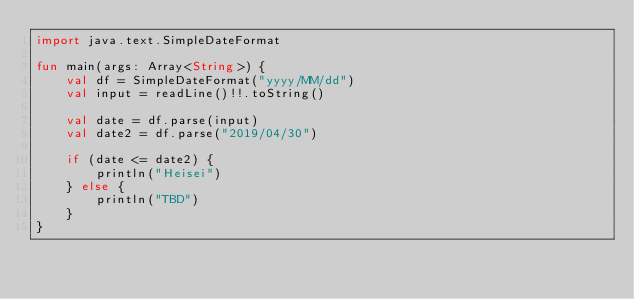<code> <loc_0><loc_0><loc_500><loc_500><_Kotlin_>import java.text.SimpleDateFormat

fun main(args: Array<String>) {
    val df = SimpleDateFormat("yyyy/MM/dd")
    val input = readLine()!!.toString()

    val date = df.parse(input)
    val date2 = df.parse("2019/04/30")

    if (date <= date2) {
        println("Heisei")
    } else {
        println("TBD")
    }
}</code> 